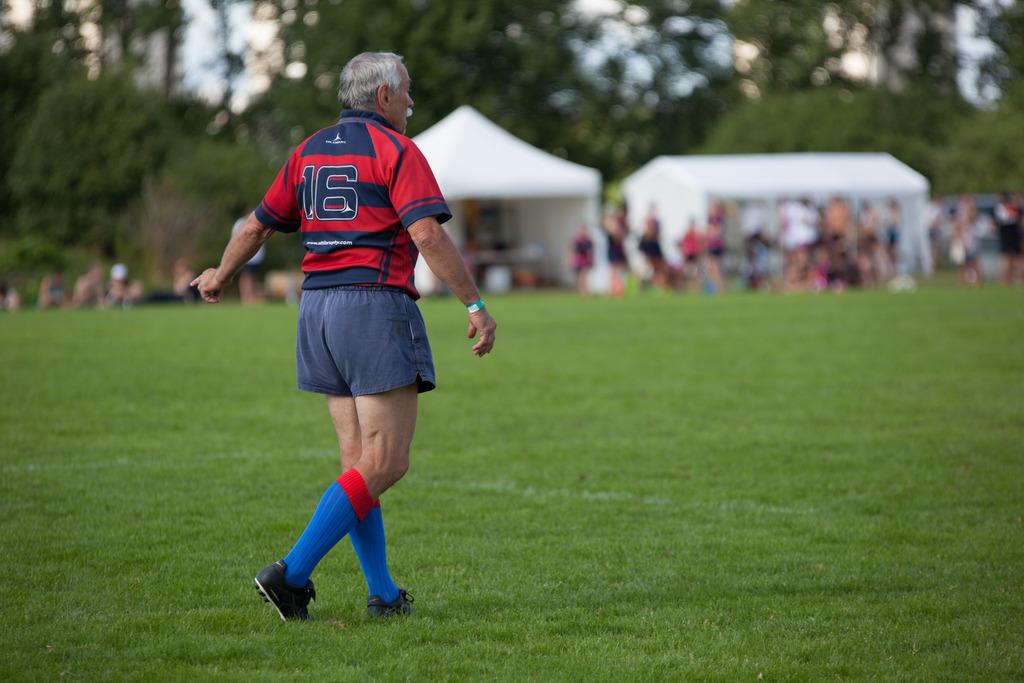What is the person in the image wearing? The person is wearing a sports dress in the image. What is the person doing in the image? The person is walking on the grassland. Are there any other people in the image? Yes, there are other persons on the grassland. What can be seen in the background of the image? There are two tents and trees in the background. background. What is the person's father doing in the image? There is no information about the person's father in the image, so we cannot answer this question. 